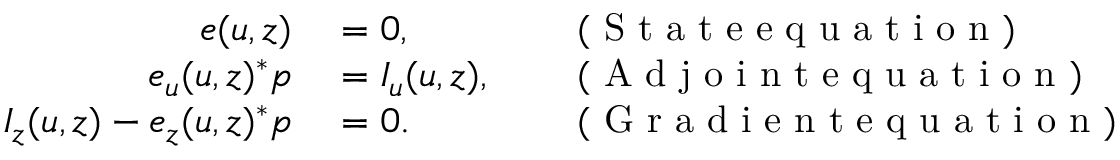Convert formula to latex. <formula><loc_0><loc_0><loc_500><loc_500>\begin{array} { r l r l } { e ( u , z ) } & = 0 , } & ( S t a t e e q u a t i o n ) } \\ { e _ { u } ( u , z ) ^ { * } p } & = I _ { u } ( u , z ) , } & ( A d j o i n t e q u a t i o n ) } \\ { I _ { z } ( u , z ) - e _ { z } ( u , z ) ^ { * } p } & = 0 . } & ( G r a d i e n t e q u a t i o n ) } \end{array}</formula> 